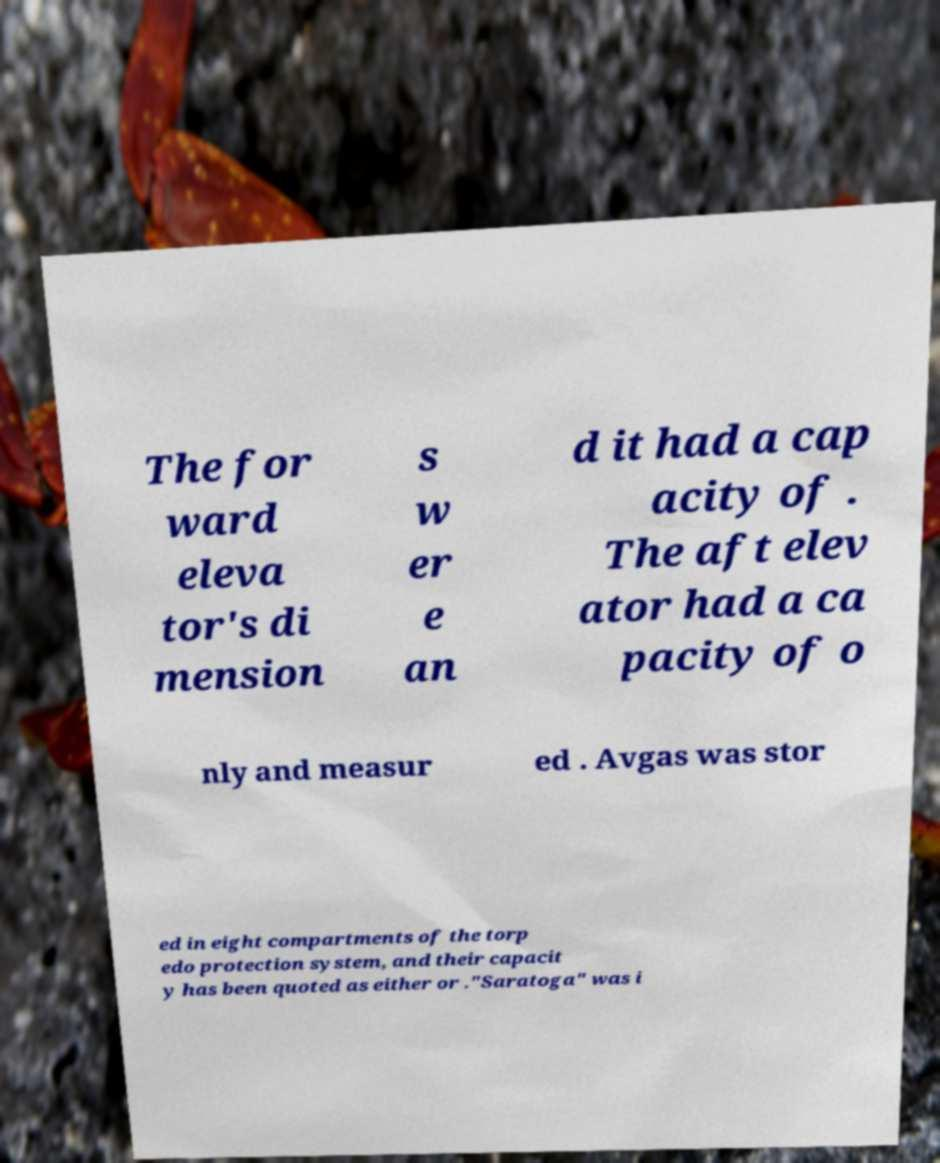Please read and relay the text visible in this image. What does it say? The for ward eleva tor's di mension s w er e an d it had a cap acity of . The aft elev ator had a ca pacity of o nly and measur ed . Avgas was stor ed in eight compartments of the torp edo protection system, and their capacit y has been quoted as either or ."Saratoga" was i 